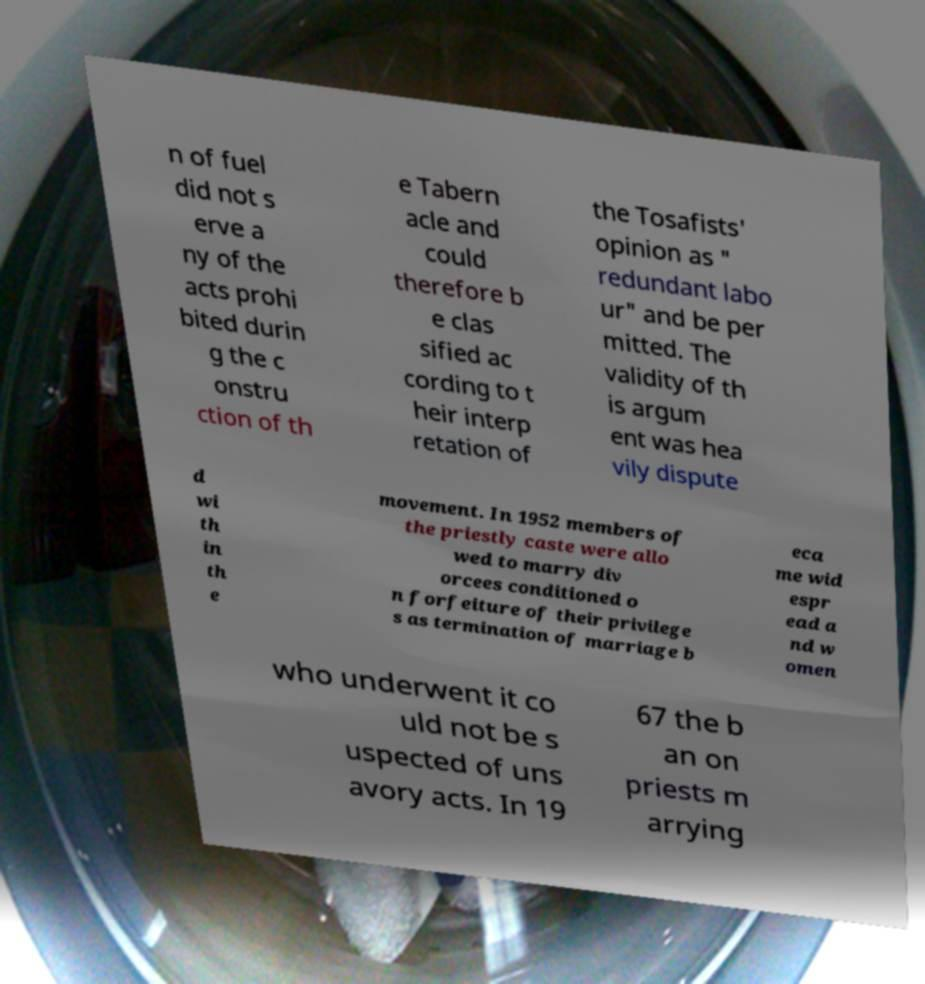I need the written content from this picture converted into text. Can you do that? n of fuel did not s erve a ny of the acts prohi bited durin g the c onstru ction of th e Tabern acle and could therefore b e clas sified ac cording to t heir interp retation of the Tosafists' opinion as " redundant labo ur" and be per mitted. The validity of th is argum ent was hea vily dispute d wi th in th e movement. In 1952 members of the priestly caste were allo wed to marry div orcees conditioned o n forfeiture of their privilege s as termination of marriage b eca me wid espr ead a nd w omen who underwent it co uld not be s uspected of uns avory acts. In 19 67 the b an on priests m arrying 